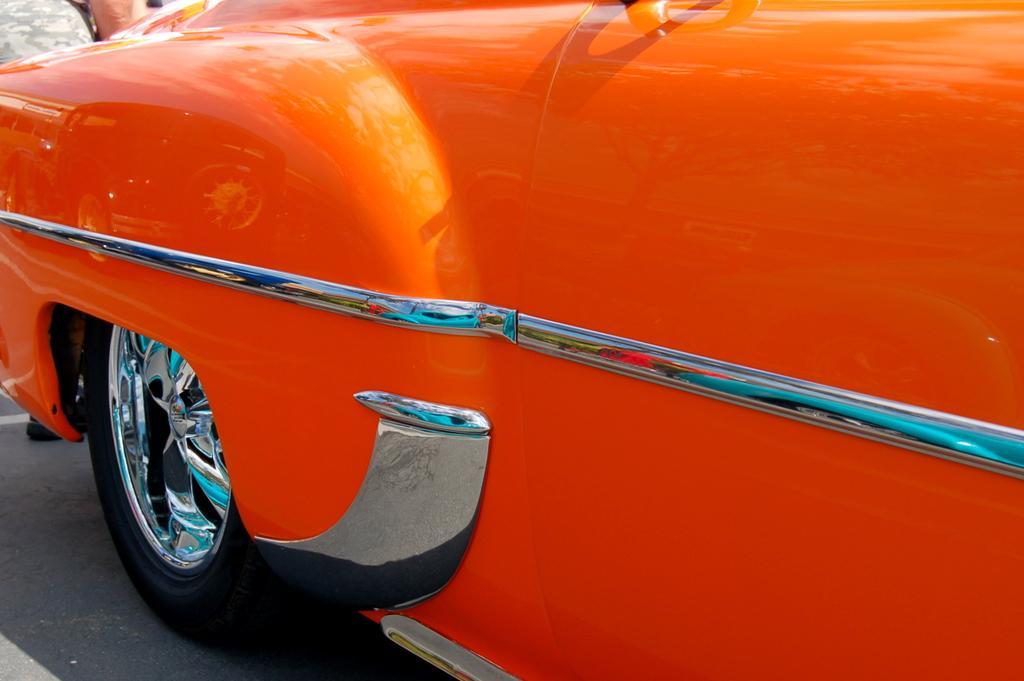Could you give a brief overview of what you see in this image? In this image there is a orange color car on the road. Behind there is a person standing on the road. 